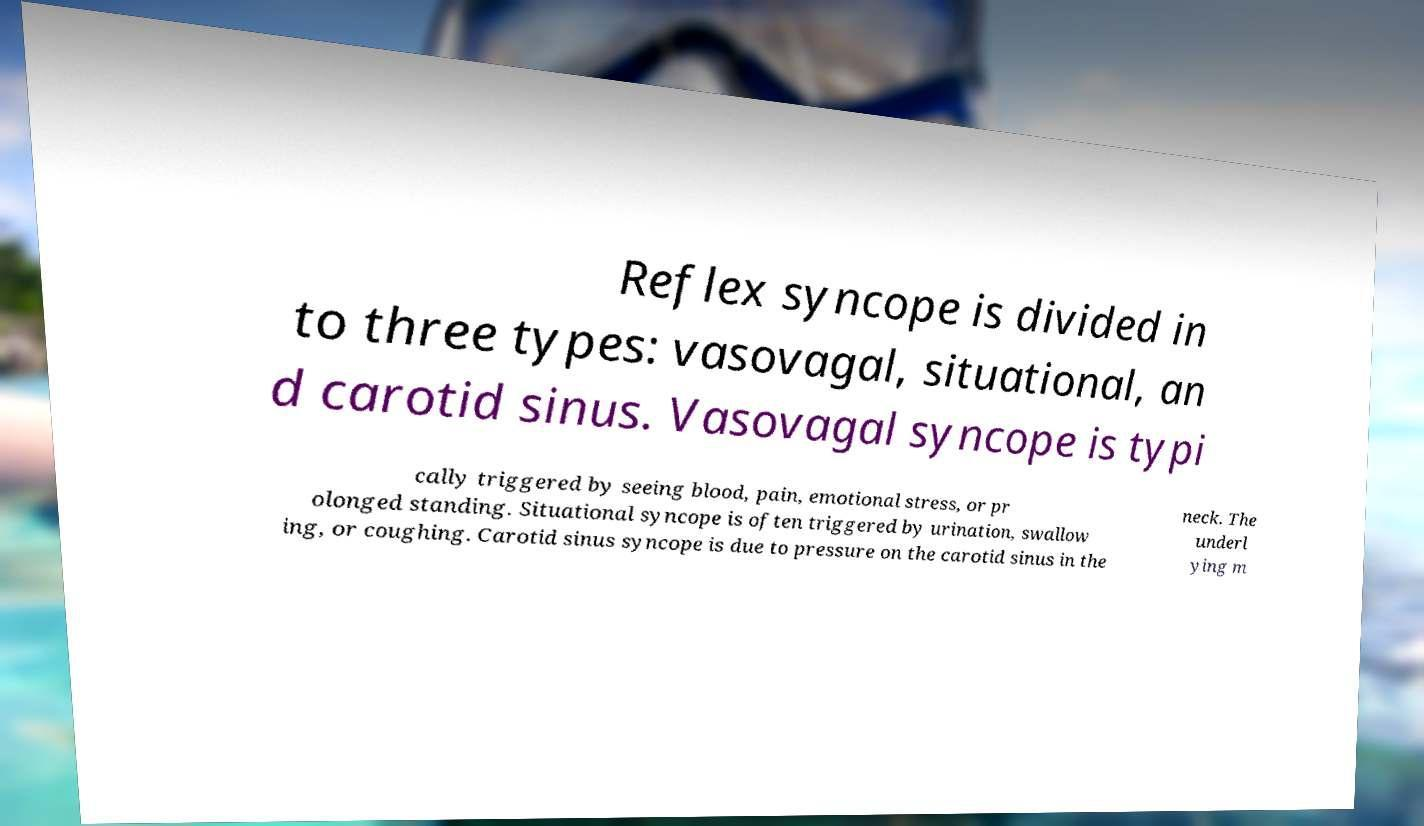For documentation purposes, I need the text within this image transcribed. Could you provide that? Reflex syncope is divided in to three types: vasovagal, situational, an d carotid sinus. Vasovagal syncope is typi cally triggered by seeing blood, pain, emotional stress, or pr olonged standing. Situational syncope is often triggered by urination, swallow ing, or coughing. Carotid sinus syncope is due to pressure on the carotid sinus in the neck. The underl ying m 